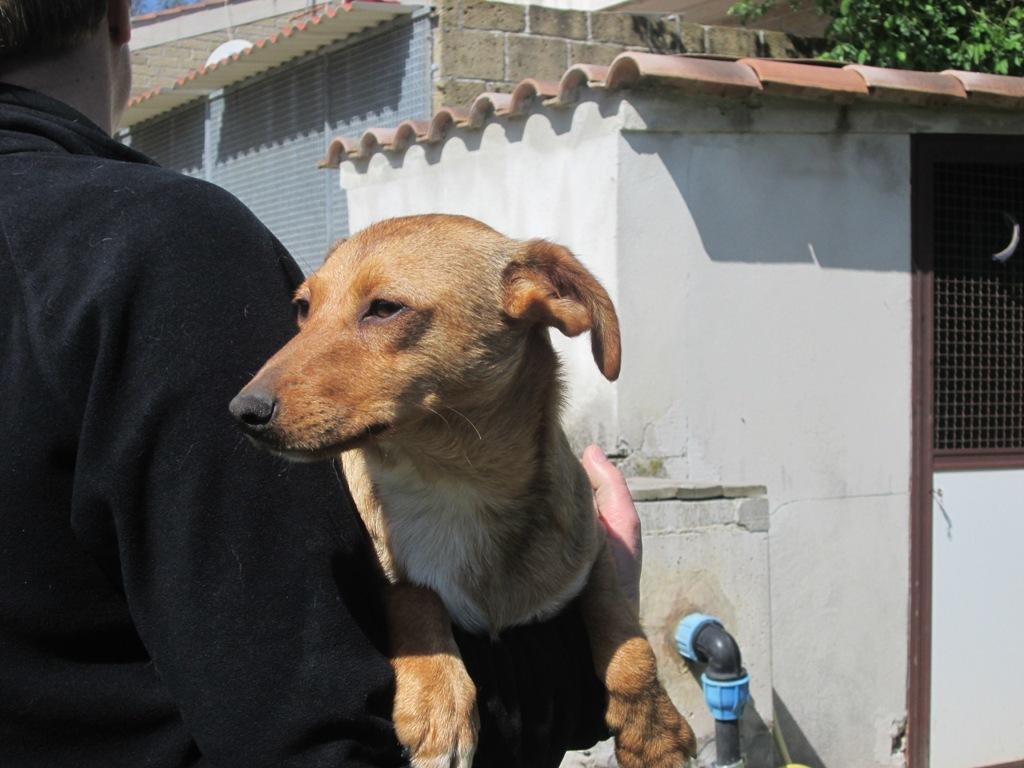Can you describe this image briefly? As we can see in the image there are houses, dog, water pipe, tree, fence and a man wearing black color dress. Here there is a rolling shutter. 